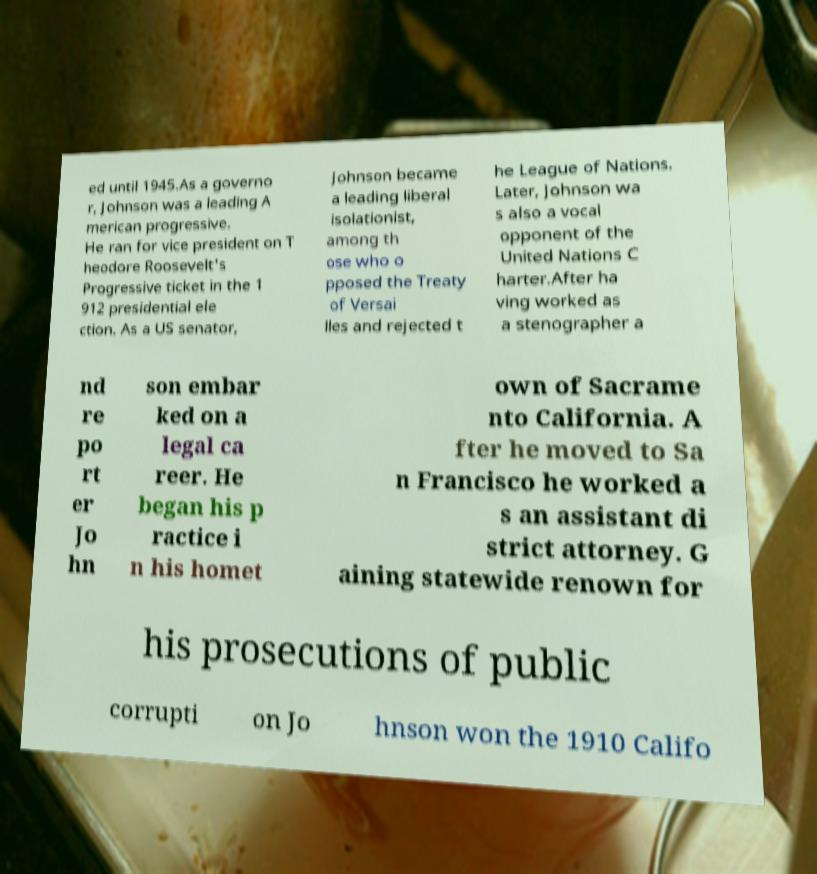Please identify and transcribe the text found in this image. ed until 1945.As a governo r, Johnson was a leading A merican progressive. He ran for vice president on T heodore Roosevelt's Progressive ticket in the 1 912 presidential ele ction. As a US senator, Johnson became a leading liberal isolationist, among th ose who o pposed the Treaty of Versai lles and rejected t he League of Nations. Later, Johnson wa s also a vocal opponent of the United Nations C harter.After ha ving worked as a stenographer a nd re po rt er Jo hn son embar ked on a legal ca reer. He began his p ractice i n his homet own of Sacrame nto California. A fter he moved to Sa n Francisco he worked a s an assistant di strict attorney. G aining statewide renown for his prosecutions of public corrupti on Jo hnson won the 1910 Califo 